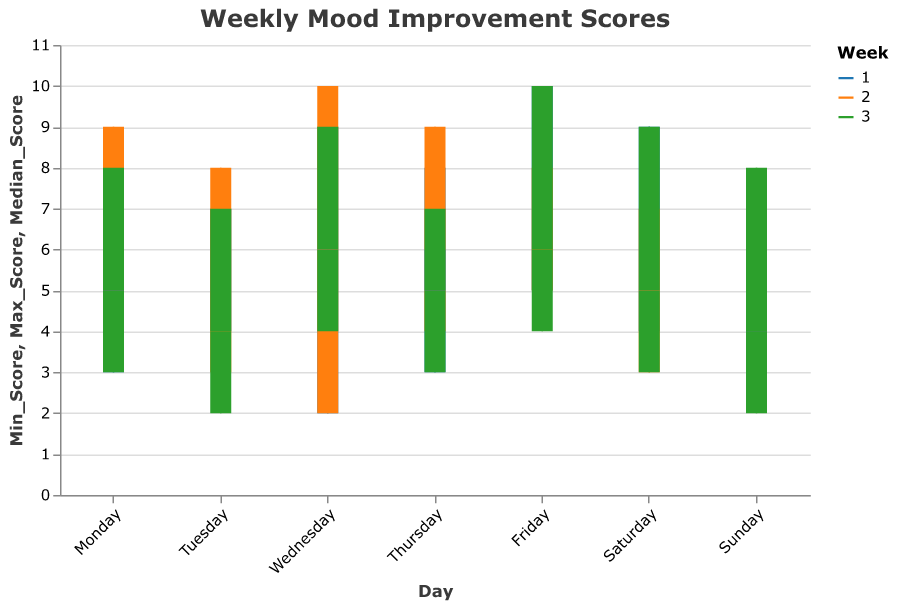What is the title of the chart? The title is located at the top of the chart and is generally very prominent in the figure. The font size and style help make the title easy to identify.
Answer: Weekly Mood Improvement Scores How many weeks of data are represented in the chart? Different colors represent distinct weeks. By looking at the legend, one can identify the number of weeks that are represented with unique colors.
Answer: 3 Which day shows the maximum median score in Week 1? To find this, we look for the day within Week 1 where the bar (representing the median score) is the highest on the y-axis.
Answer: Friday On which day in Week 2 is the minimum mood score the lowest? To determine this, look for the smallest bottom point of the vertical rule in Week 2.
Answer: Wednesday Is the range of mood improvement scores (Min to Max) wider on Friday of Week 1 or Friday of Week 3? We need to compare the distance between Min and Max scores for the two days. The wider the span of the rule on the y-axis, the greater the range.
Answer: Week 1 What is the average median score for Sundays across all three weeks? The median scores for Sundays in each week are 5, 5, and 4. Adding these together and dividing by 3 gives the average. Calculation: (5+5+4)/3 = 14/3 = 4.67
Answer: 4.67 Did Saturdays generally show a higher median score compared to Sundays across the weeks? We compare the heights of the bars representing median scores for Saturdays and Sundays across the three weeks. Each bar's height shows the median score.
Answer: Yes Which week shows the highest maximum score, and on which day does this occur? We look for the highest top point of the vertical rules across all days and weeks.
Answer: Week 1, Friday What is the difference in the median scores between Tuesday and Wednesday of Week 3? Find the median scores for Tuesday and Wednesday in Week 3 and subtract the Tuesday score from the Wednesday score. Median for Tuesday is 4, and for Wednesday is 6. Calculation: 6 - 4 = 2
Answer: 2 What is the median mood score on Wednesday of Week 2? To find this, locate the bar for Wednesday of Week 2 and note the value at the center of the bar, which is the median score.
Answer: 6 